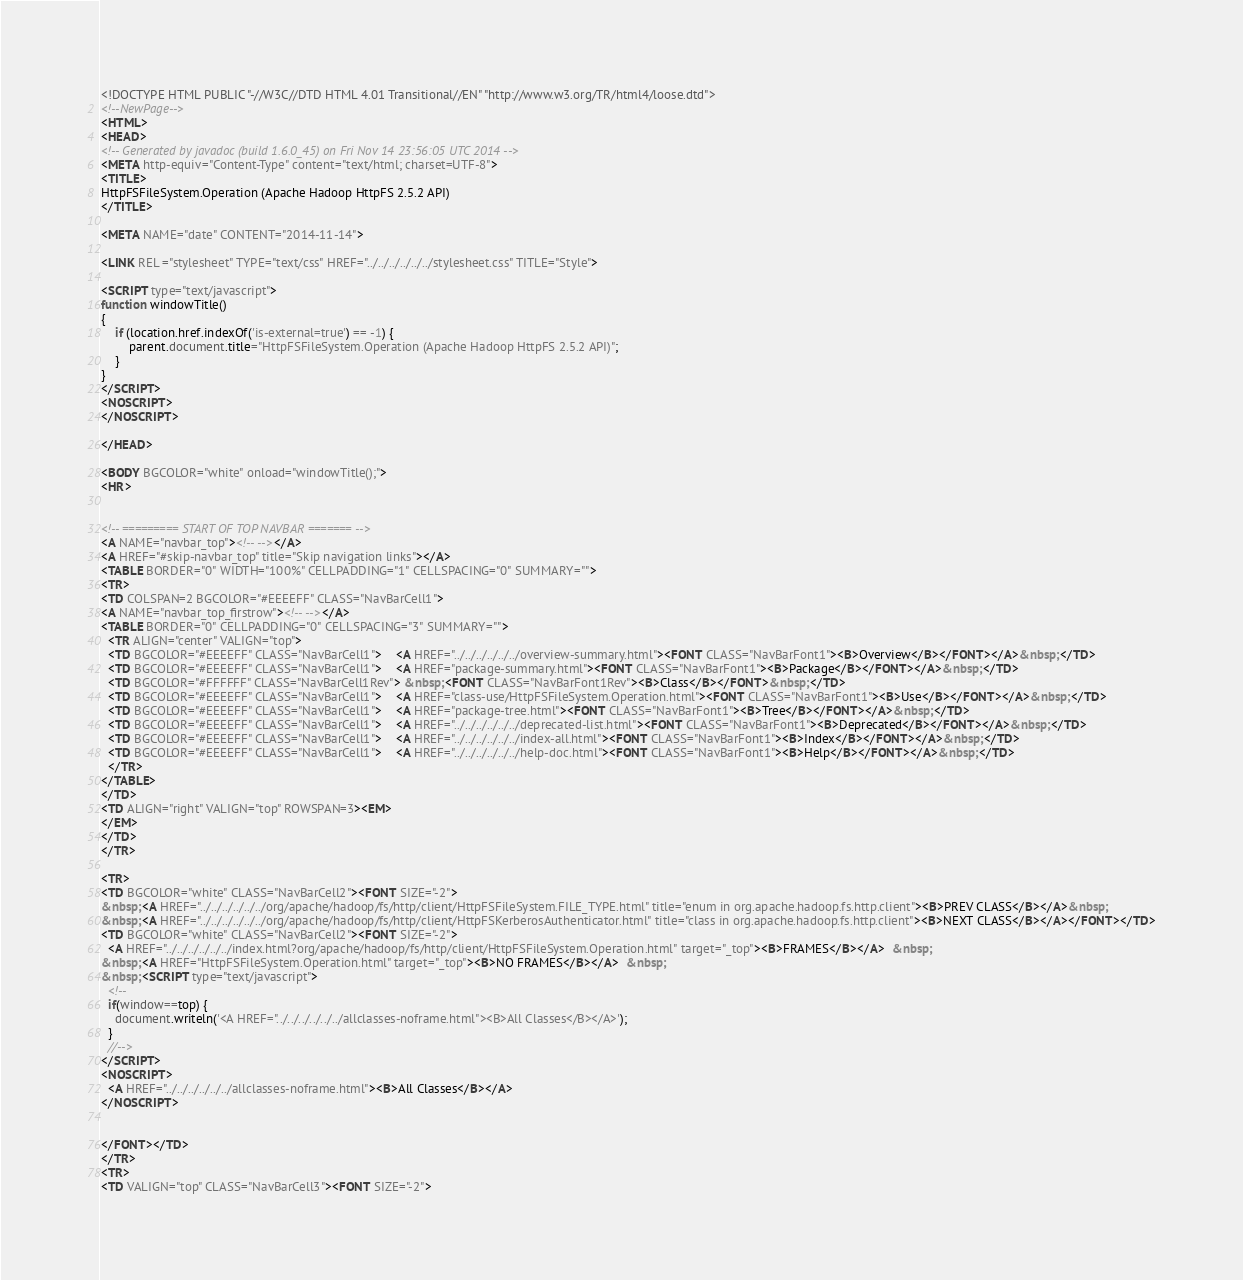Convert code to text. <code><loc_0><loc_0><loc_500><loc_500><_HTML_><!DOCTYPE HTML PUBLIC "-//W3C//DTD HTML 4.01 Transitional//EN" "http://www.w3.org/TR/html4/loose.dtd">
<!--NewPage-->
<HTML>
<HEAD>
<!-- Generated by javadoc (build 1.6.0_45) on Fri Nov 14 23:56:05 UTC 2014 -->
<META http-equiv="Content-Type" content="text/html; charset=UTF-8">
<TITLE>
HttpFSFileSystem.Operation (Apache Hadoop HttpFS 2.5.2 API)
</TITLE>

<META NAME="date" CONTENT="2014-11-14">

<LINK REL ="stylesheet" TYPE="text/css" HREF="../../../../../../stylesheet.css" TITLE="Style">

<SCRIPT type="text/javascript">
function windowTitle()
{
    if (location.href.indexOf('is-external=true') == -1) {
        parent.document.title="HttpFSFileSystem.Operation (Apache Hadoop HttpFS 2.5.2 API)";
    }
}
</SCRIPT>
<NOSCRIPT>
</NOSCRIPT>

</HEAD>

<BODY BGCOLOR="white" onload="windowTitle();">
<HR>


<!-- ========= START OF TOP NAVBAR ======= -->
<A NAME="navbar_top"><!-- --></A>
<A HREF="#skip-navbar_top" title="Skip navigation links"></A>
<TABLE BORDER="0" WIDTH="100%" CELLPADDING="1" CELLSPACING="0" SUMMARY="">
<TR>
<TD COLSPAN=2 BGCOLOR="#EEEEFF" CLASS="NavBarCell1">
<A NAME="navbar_top_firstrow"><!-- --></A>
<TABLE BORDER="0" CELLPADDING="0" CELLSPACING="3" SUMMARY="">
  <TR ALIGN="center" VALIGN="top">
  <TD BGCOLOR="#EEEEFF" CLASS="NavBarCell1">    <A HREF="../../../../../../overview-summary.html"><FONT CLASS="NavBarFont1"><B>Overview</B></FONT></A>&nbsp;</TD>
  <TD BGCOLOR="#EEEEFF" CLASS="NavBarCell1">    <A HREF="package-summary.html"><FONT CLASS="NavBarFont1"><B>Package</B></FONT></A>&nbsp;</TD>
  <TD BGCOLOR="#FFFFFF" CLASS="NavBarCell1Rev"> &nbsp;<FONT CLASS="NavBarFont1Rev"><B>Class</B></FONT>&nbsp;</TD>
  <TD BGCOLOR="#EEEEFF" CLASS="NavBarCell1">    <A HREF="class-use/HttpFSFileSystem.Operation.html"><FONT CLASS="NavBarFont1"><B>Use</B></FONT></A>&nbsp;</TD>
  <TD BGCOLOR="#EEEEFF" CLASS="NavBarCell1">    <A HREF="package-tree.html"><FONT CLASS="NavBarFont1"><B>Tree</B></FONT></A>&nbsp;</TD>
  <TD BGCOLOR="#EEEEFF" CLASS="NavBarCell1">    <A HREF="../../../../../../deprecated-list.html"><FONT CLASS="NavBarFont1"><B>Deprecated</B></FONT></A>&nbsp;</TD>
  <TD BGCOLOR="#EEEEFF" CLASS="NavBarCell1">    <A HREF="../../../../../../index-all.html"><FONT CLASS="NavBarFont1"><B>Index</B></FONT></A>&nbsp;</TD>
  <TD BGCOLOR="#EEEEFF" CLASS="NavBarCell1">    <A HREF="../../../../../../help-doc.html"><FONT CLASS="NavBarFont1"><B>Help</B></FONT></A>&nbsp;</TD>
  </TR>
</TABLE>
</TD>
<TD ALIGN="right" VALIGN="top" ROWSPAN=3><EM>
</EM>
</TD>
</TR>

<TR>
<TD BGCOLOR="white" CLASS="NavBarCell2"><FONT SIZE="-2">
&nbsp;<A HREF="../../../../../../org/apache/hadoop/fs/http/client/HttpFSFileSystem.FILE_TYPE.html" title="enum in org.apache.hadoop.fs.http.client"><B>PREV CLASS</B></A>&nbsp;
&nbsp;<A HREF="../../../../../../org/apache/hadoop/fs/http/client/HttpFSKerberosAuthenticator.html" title="class in org.apache.hadoop.fs.http.client"><B>NEXT CLASS</B></A></FONT></TD>
<TD BGCOLOR="white" CLASS="NavBarCell2"><FONT SIZE="-2">
  <A HREF="../../../../../../index.html?org/apache/hadoop/fs/http/client/HttpFSFileSystem.Operation.html" target="_top"><B>FRAMES</B></A>  &nbsp;
&nbsp;<A HREF="HttpFSFileSystem.Operation.html" target="_top"><B>NO FRAMES</B></A>  &nbsp;
&nbsp;<SCRIPT type="text/javascript">
  <!--
  if(window==top) {
    document.writeln('<A HREF="../../../../../../allclasses-noframe.html"><B>All Classes</B></A>');
  }
  //-->
</SCRIPT>
<NOSCRIPT>
  <A HREF="../../../../../../allclasses-noframe.html"><B>All Classes</B></A>
</NOSCRIPT>


</FONT></TD>
</TR>
<TR>
<TD VALIGN="top" CLASS="NavBarCell3"><FONT SIZE="-2"></code> 